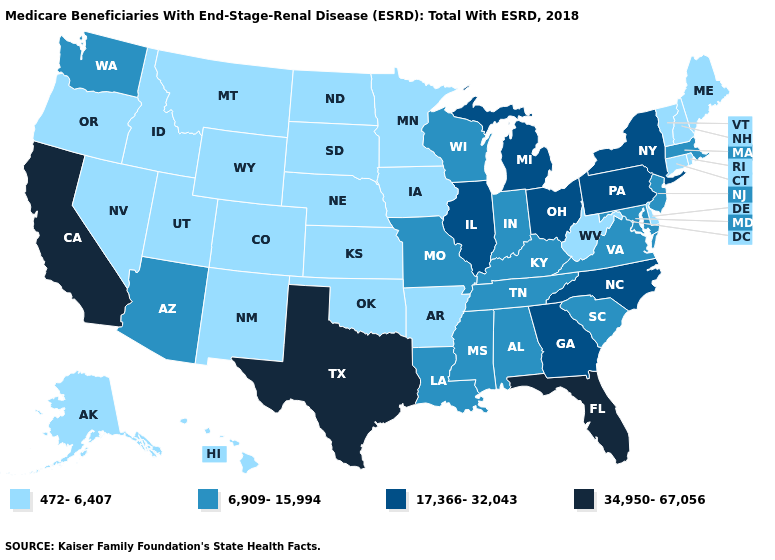Does Michigan have the highest value in the MidWest?
Give a very brief answer. Yes. Name the states that have a value in the range 472-6,407?
Answer briefly. Alaska, Arkansas, Colorado, Connecticut, Delaware, Hawaii, Idaho, Iowa, Kansas, Maine, Minnesota, Montana, Nebraska, Nevada, New Hampshire, New Mexico, North Dakota, Oklahoma, Oregon, Rhode Island, South Dakota, Utah, Vermont, West Virginia, Wyoming. Among the states that border West Virginia , which have the highest value?
Write a very short answer. Ohio, Pennsylvania. Among the states that border Alabama , which have the lowest value?
Write a very short answer. Mississippi, Tennessee. Does California have the highest value in the West?
Short answer required. Yes. Does Arizona have the lowest value in the West?
Concise answer only. No. How many symbols are there in the legend?
Quick response, please. 4. What is the lowest value in the USA?
Be succinct. 472-6,407. What is the value of Alaska?
Answer briefly. 472-6,407. Does California have the lowest value in the West?
Be succinct. No. What is the highest value in the West ?
Quick response, please. 34,950-67,056. Which states hav the highest value in the Northeast?
Concise answer only. New York, Pennsylvania. What is the value of Arizona?
Write a very short answer. 6,909-15,994. Which states have the highest value in the USA?
Give a very brief answer. California, Florida, Texas. 